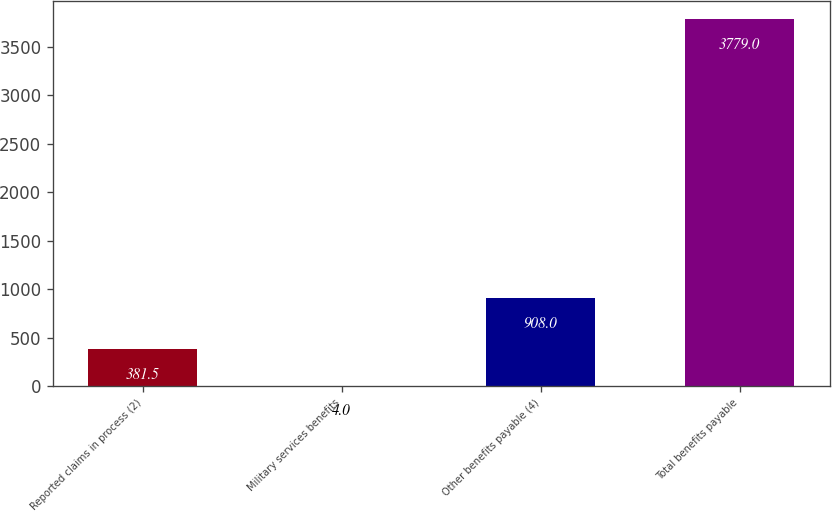<chart> <loc_0><loc_0><loc_500><loc_500><bar_chart><fcel>Reported claims in process (2)<fcel>Military services benefits<fcel>Other benefits payable (4)<fcel>Total benefits payable<nl><fcel>381.5<fcel>4<fcel>908<fcel>3779<nl></chart> 